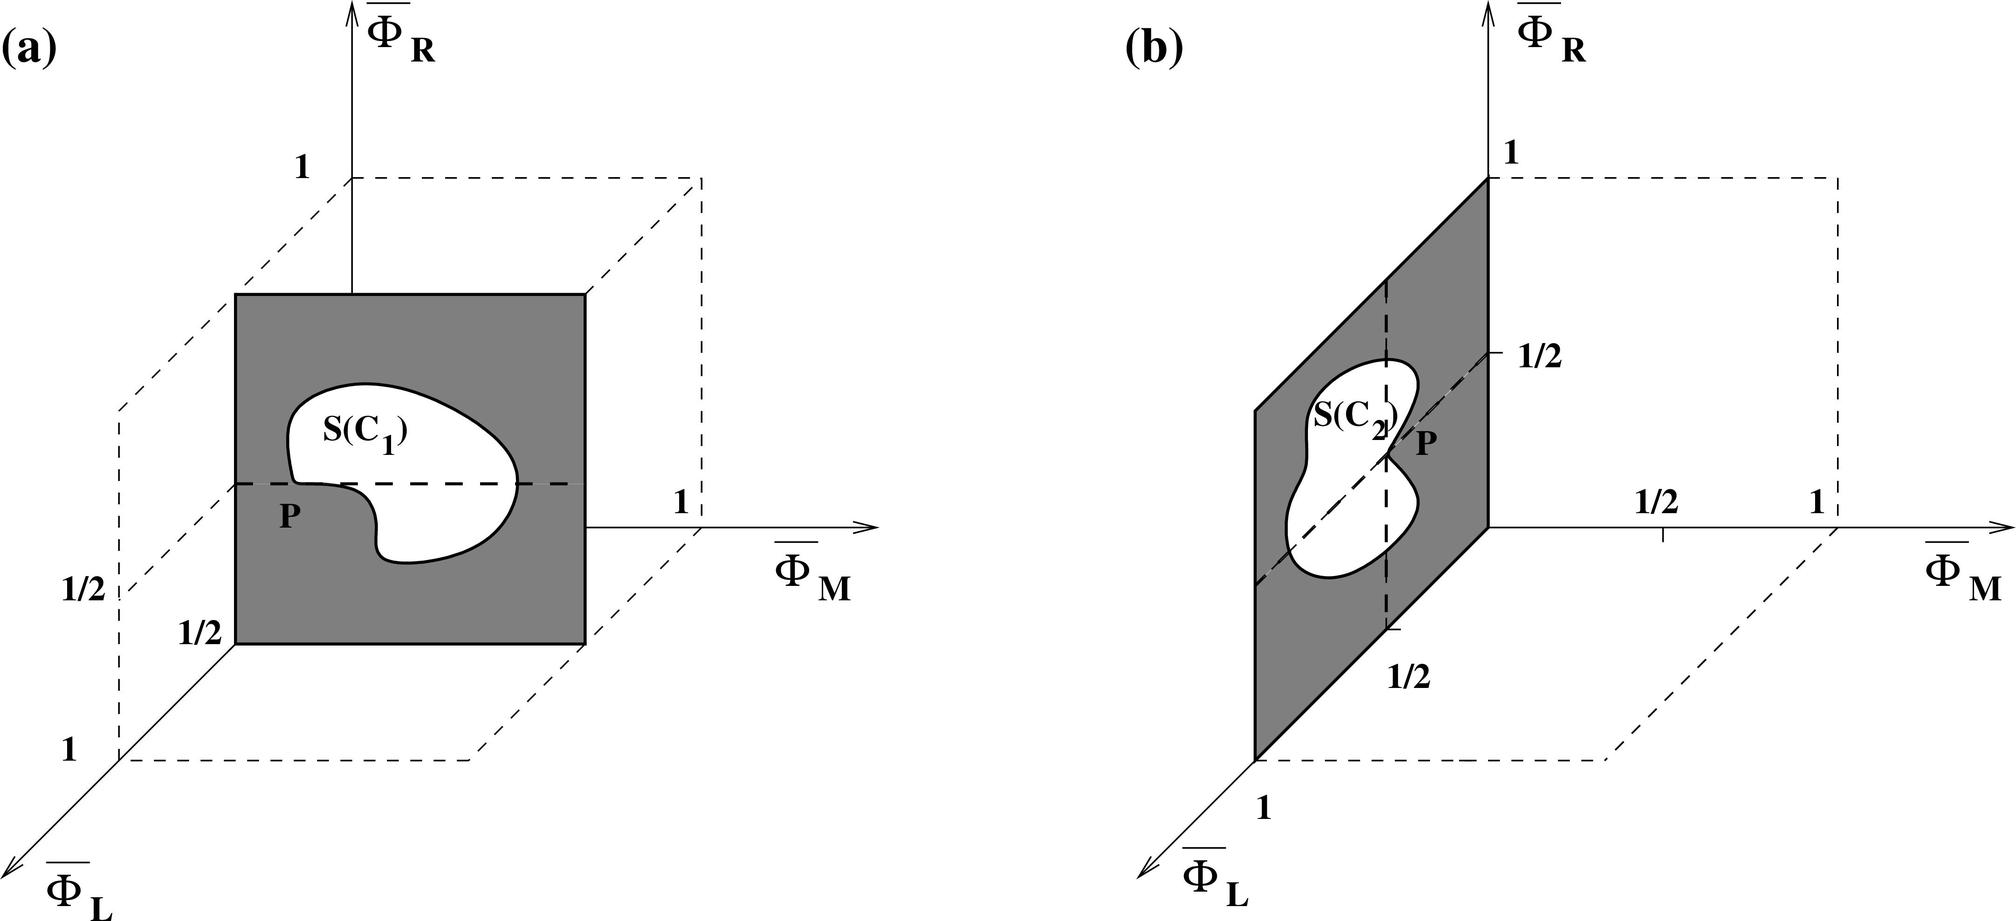What could these figures typically represent in a practical application? These figures could represent a range of practical applications, particularly in fields like materials science, mechanical engineering, or geometry. For instance, in materials science, these diagrams might be used to study the stress distribution within a composite material where Islam and R could represent different stress or strain dimensions. In mechanical engineering, similar diagrams could be useful in analyzing the structural integrity of components depending on the shape and distribution of materials within given parameters.  How do these representations help in understanding the properties of materials? By analyzing these types of schematics, engineers and scientists can infer how materials will behave under different conditions. The illustrations might help in visualizing and predicting how changes in the geometry (such as shape and size of regions like S(C1) and S(C2)) impact material properties like stress distribution and load-bearing capacity. Understanding these aspects allows for designing materials that are optimally suited for specific applications, enhancing both performance and safety. 